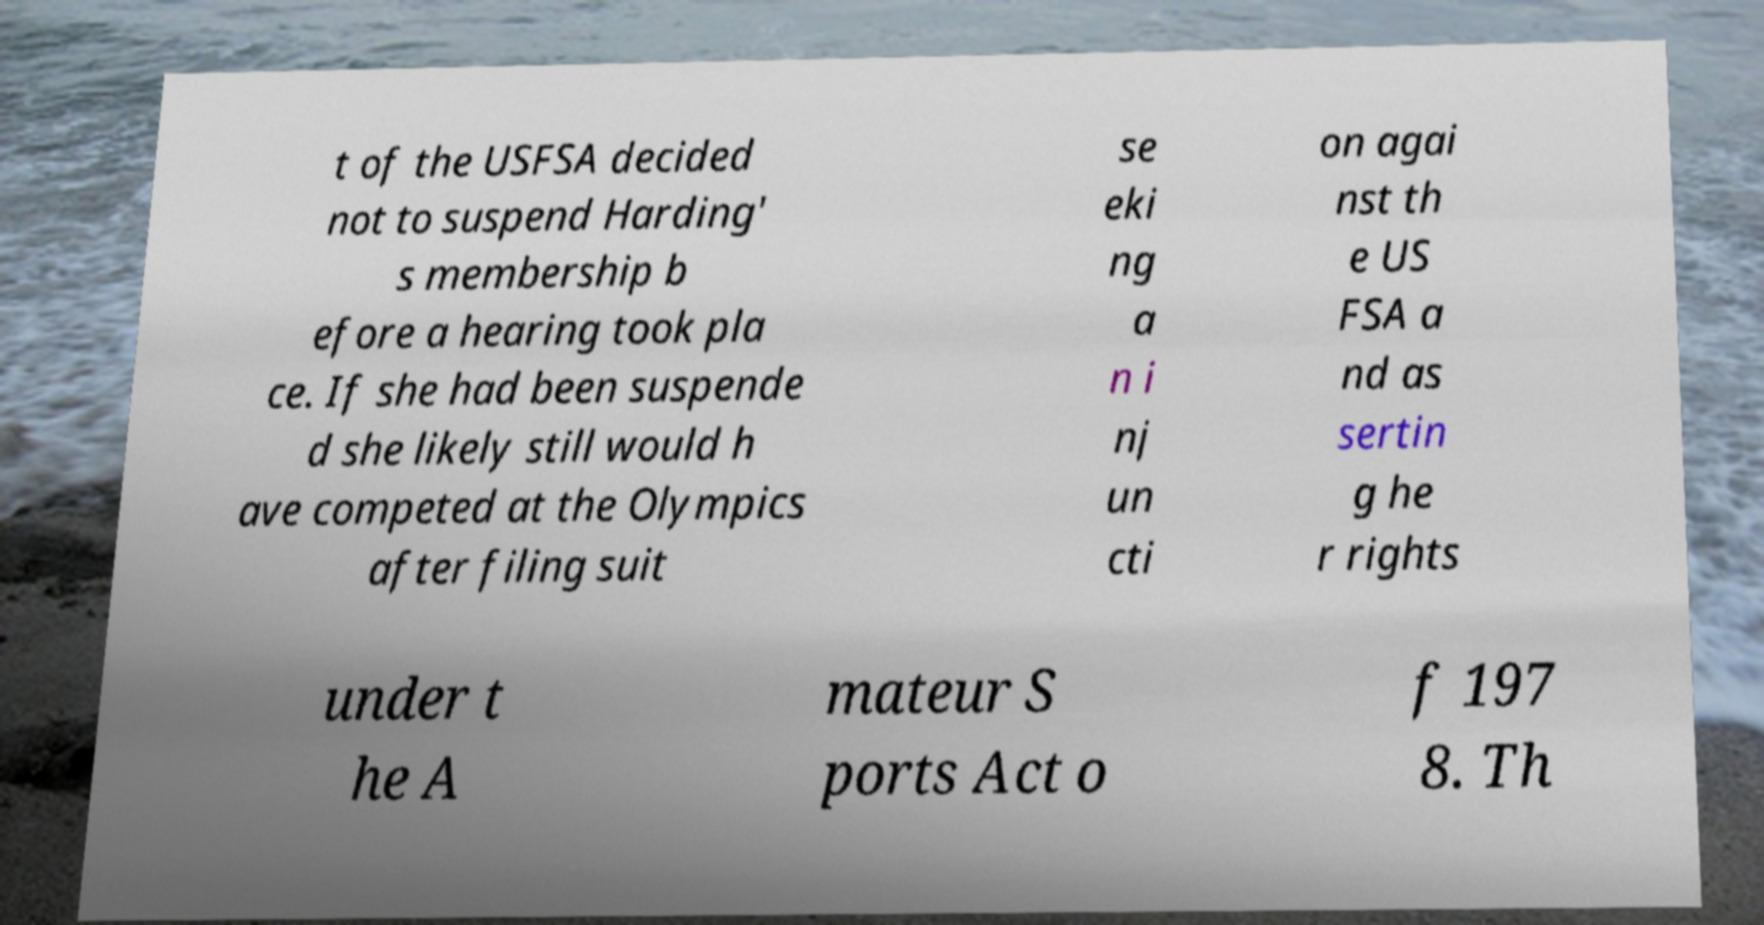Can you accurately transcribe the text from the provided image for me? t of the USFSA decided not to suspend Harding' s membership b efore a hearing took pla ce. If she had been suspende d she likely still would h ave competed at the Olympics after filing suit se eki ng a n i nj un cti on agai nst th e US FSA a nd as sertin g he r rights under t he A mateur S ports Act o f 197 8. Th 